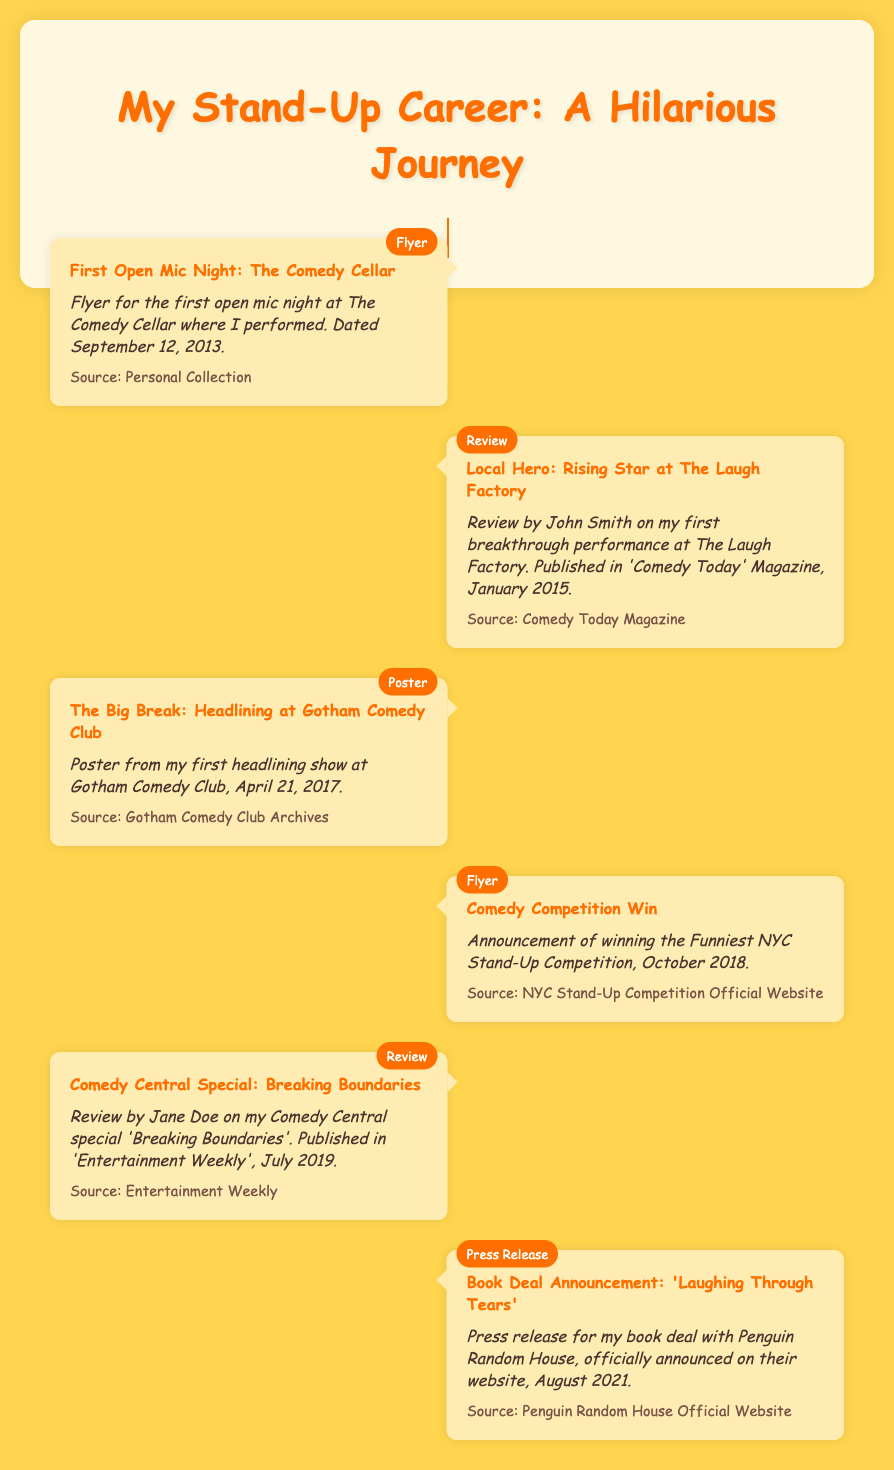What was the date of my first open mic night? The document states that the first open mic night at The Comedy Cellar was dated September 12, 2013.
Answer: September 12, 2013 Who wrote the review for my performance at The Laugh Factory? According to the document, the review of my performance at The Laugh Factory was written by John Smith.
Answer: John Smith What type of event was my first headlining show? The document describes my first headlining show at Gotham Comedy Club as a poster event.
Answer: Poster What was the year I won the Funniest NYC Stand-Up Competition? The announcement of winning the competition is dated October 2018.
Answer: 2018 Which magazine published the review of my Comedy Central special? The review of my Comedy Central special 'Breaking Boundaries' was published in Entertainment Weekly.
Answer: Entertainment Weekly How many events are listed in the timeline? The document contains a total of six key events in my stand-up career.
Answer: Six What type of document is this timeline considered? This timeline is a bibliography, highlighting key milestones in my stand-up career supported by various materials.
Answer: Bibliography What was announced in August 2021? The document states that a press release for my book deal with Penguin Random House was announced in August 2021.
Answer: Book deal What is the title of my book mentioned in the document? The title of my book, as mentioned in the document, is 'Laughing Through Tears'.
Answer: Laughing Through Tears 